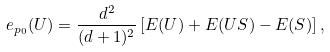<formula> <loc_0><loc_0><loc_500><loc_500>e _ { p _ { 0 } } ( U ) = \frac { d ^ { 2 } } { ( d + 1 ) ^ { 2 } } \left [ E ( U ) + E ( U S ) - E ( S ) \right ] ,</formula> 